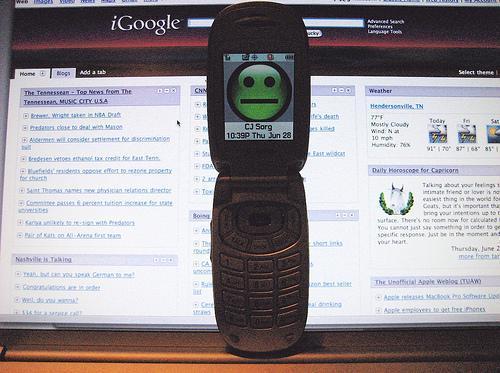How many cell phones can be seen?
Give a very brief answer. 1. 